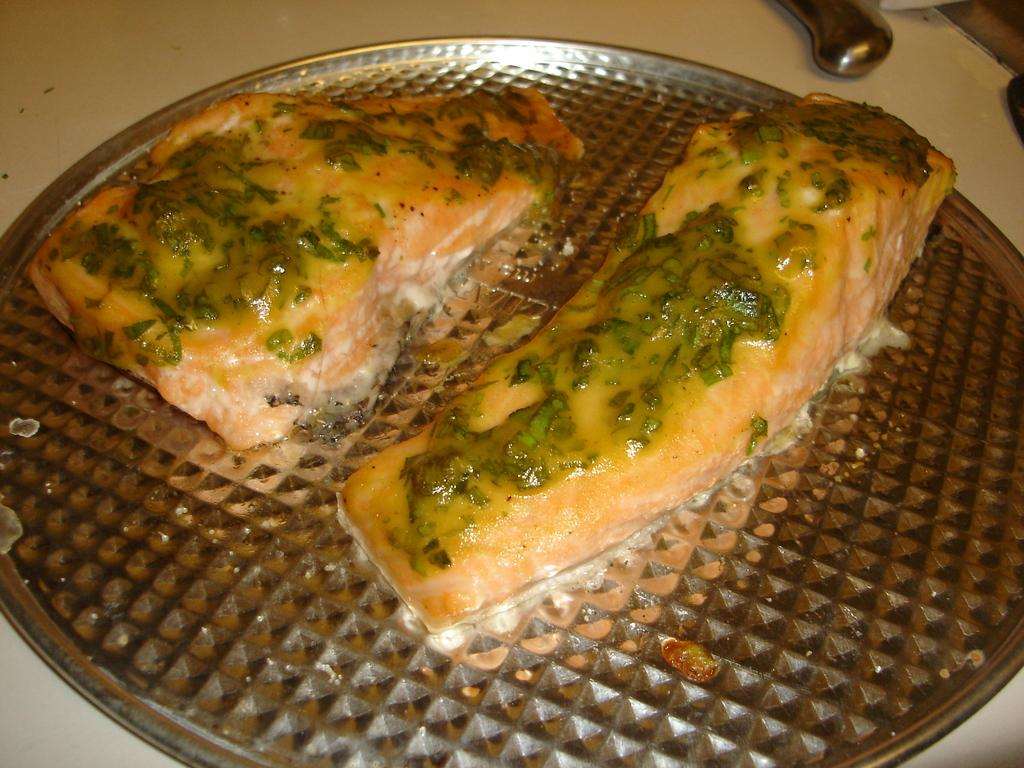What is on the plate in the image? There are food items on a plate in the image. What utensil can be seen in the image? There is a knife placed on a white surface in the image. What type of clouds can be seen in the image? There are no clouds visible in the image, as it only features food items on a plate and a knife on a white surface. What time of day is it in the image? The time of day cannot be determined from the image, as there are no indications of lighting or shadows that would suggest morning or any other time. 